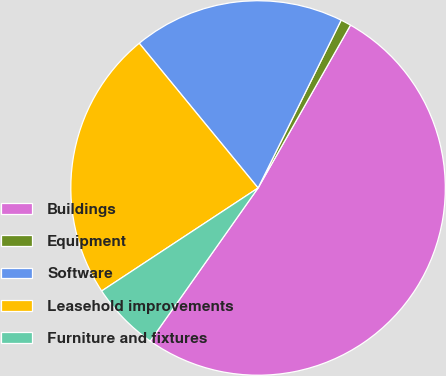Convert chart. <chart><loc_0><loc_0><loc_500><loc_500><pie_chart><fcel>Buildings<fcel>Equipment<fcel>Software<fcel>Leasehold improvements<fcel>Furniture and fixtures<nl><fcel>51.56%<fcel>0.9%<fcel>18.26%<fcel>23.33%<fcel>5.96%<nl></chart> 